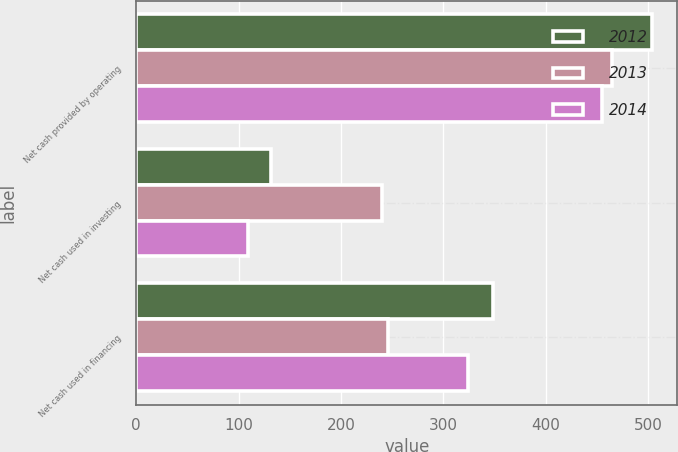<chart> <loc_0><loc_0><loc_500><loc_500><stacked_bar_chart><ecel><fcel>Net cash provided by operating<fcel>Net cash used in investing<fcel>Net cash used in financing<nl><fcel>2012<fcel>503.6<fcel>131.6<fcel>348.9<nl><fcel>2013<fcel>465.2<fcel>239.7<fcel>245.9<nl><fcel>2014<fcel>455<fcel>109<fcel>324.3<nl></chart> 